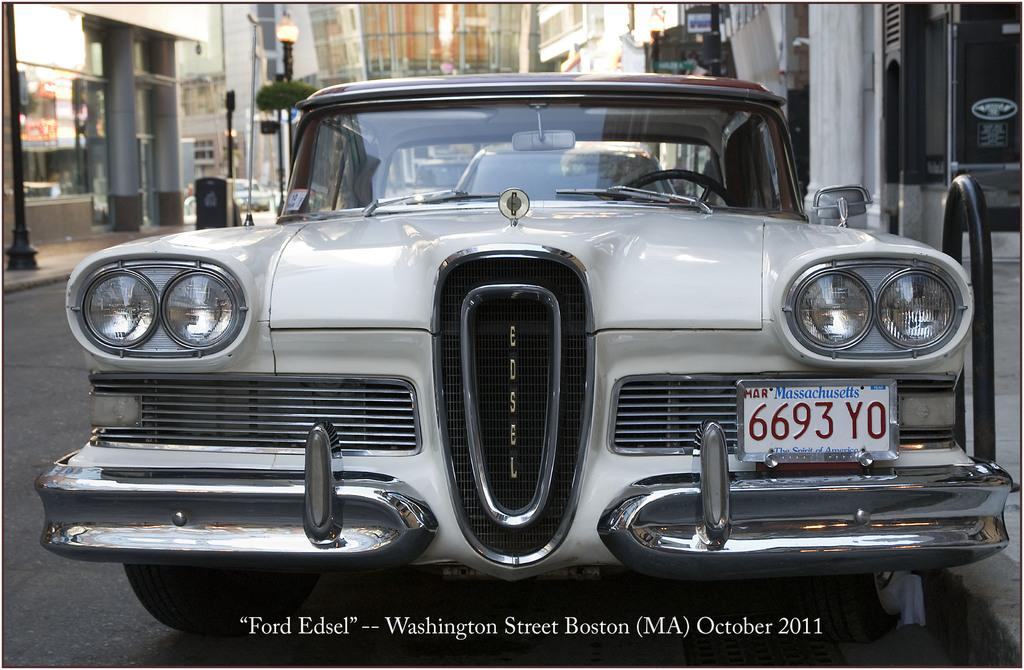<image>
Share a concise interpretation of the image provided. the front of a white car whose license plate reads 6693 yo on the bottom left side. 